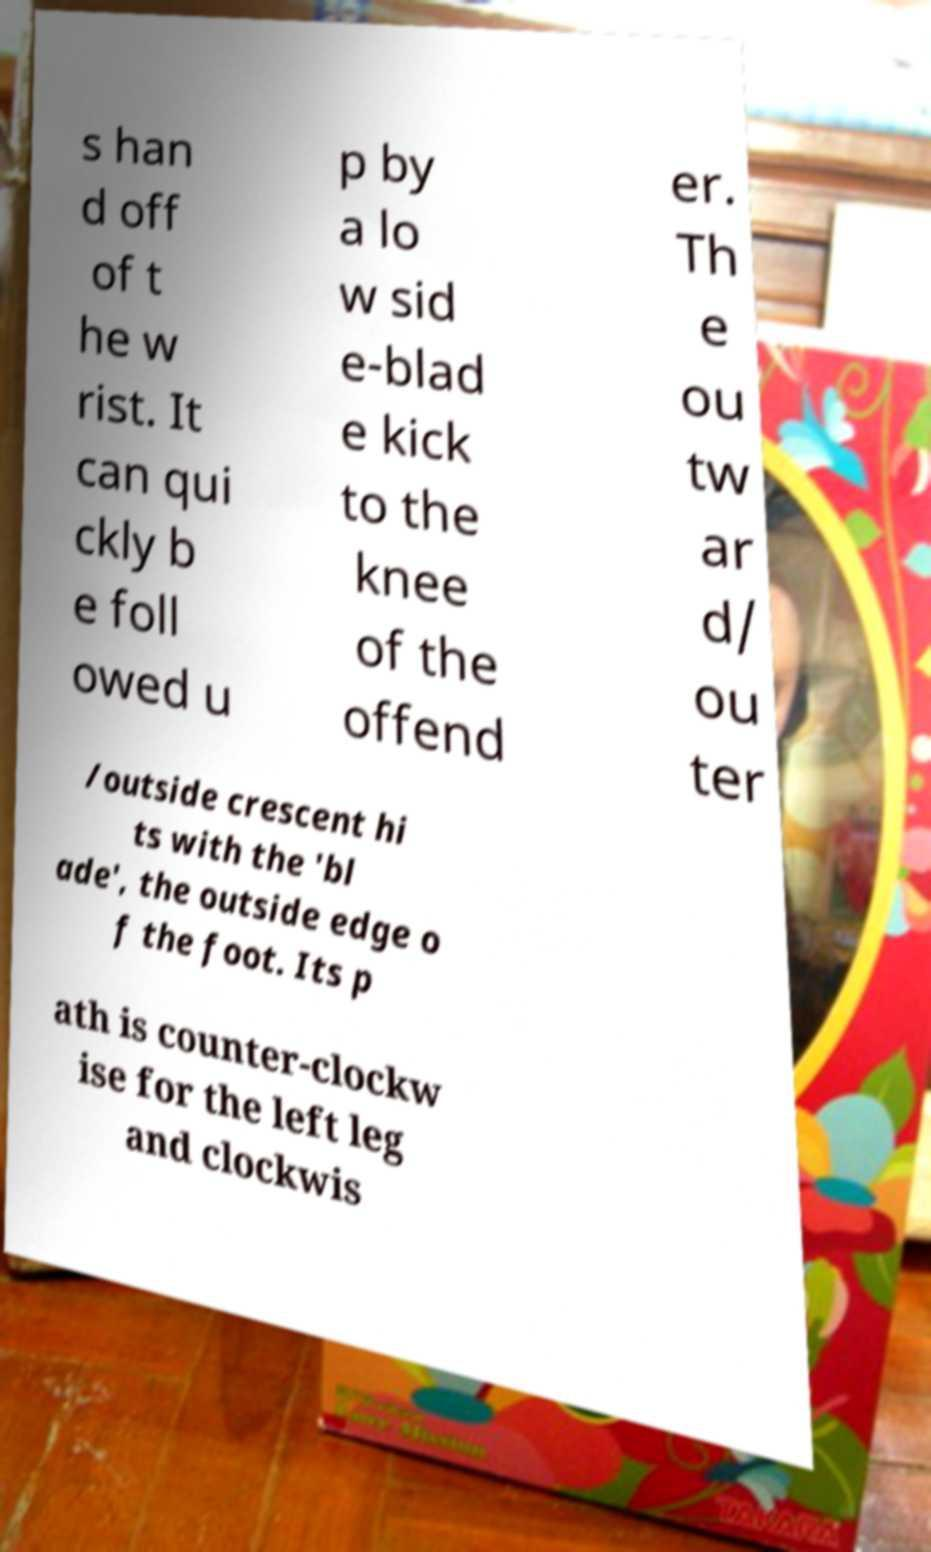Could you assist in decoding the text presented in this image and type it out clearly? s han d off of t he w rist. It can qui ckly b e foll owed u p by a lo w sid e-blad e kick to the knee of the offend er. Th e ou tw ar d/ ou ter /outside crescent hi ts with the 'bl ade', the outside edge o f the foot. Its p ath is counter-clockw ise for the left leg and clockwis 